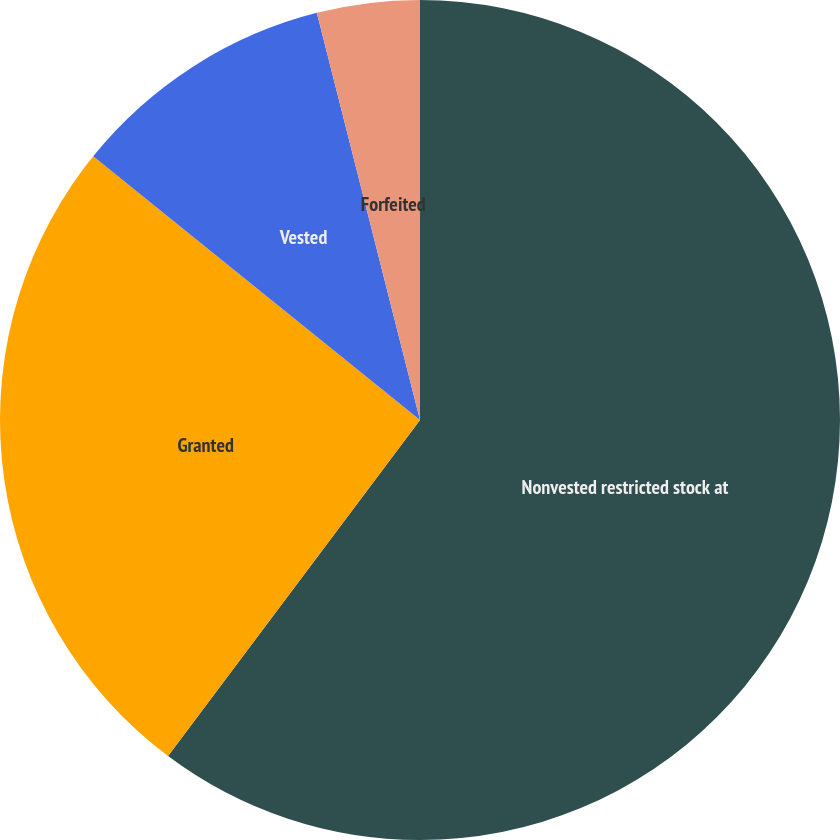Convert chart. <chart><loc_0><loc_0><loc_500><loc_500><pie_chart><fcel>Nonvested restricted stock at<fcel>Granted<fcel>Vested<fcel>Forfeited<nl><fcel>60.24%<fcel>25.57%<fcel>10.24%<fcel>3.95%<nl></chart> 